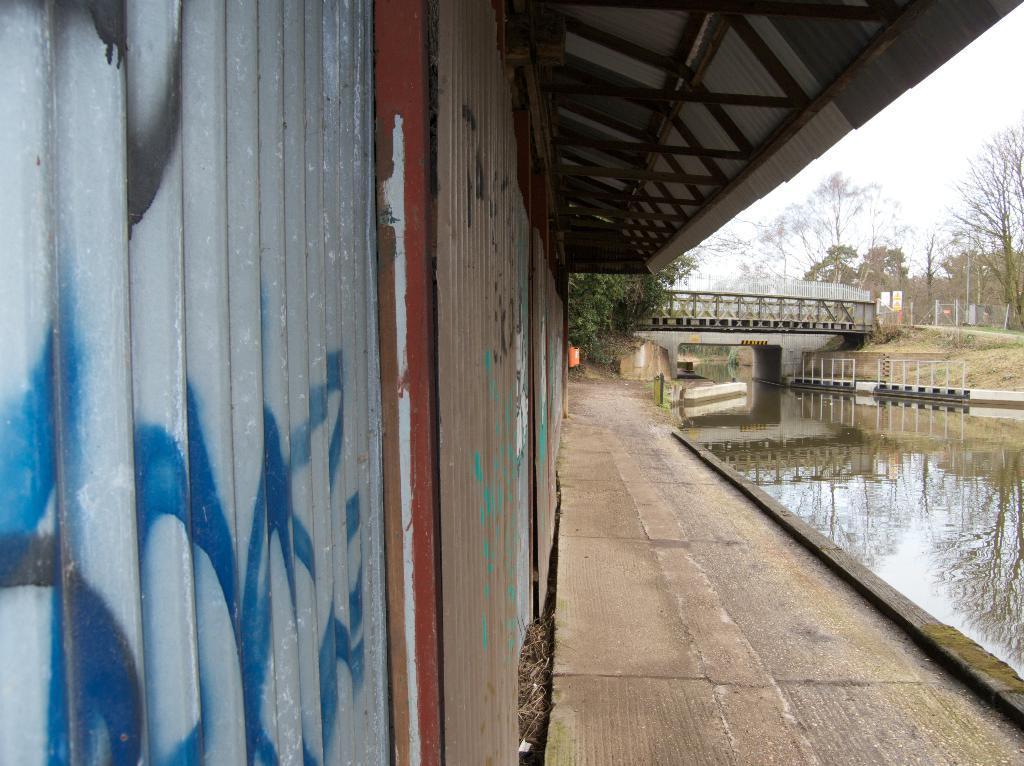Can you describe this image briefly? On the left side there is a house. On the right side there is a sea. In the background there is a bridge and many trees. At the top of the image I can see the sky. 